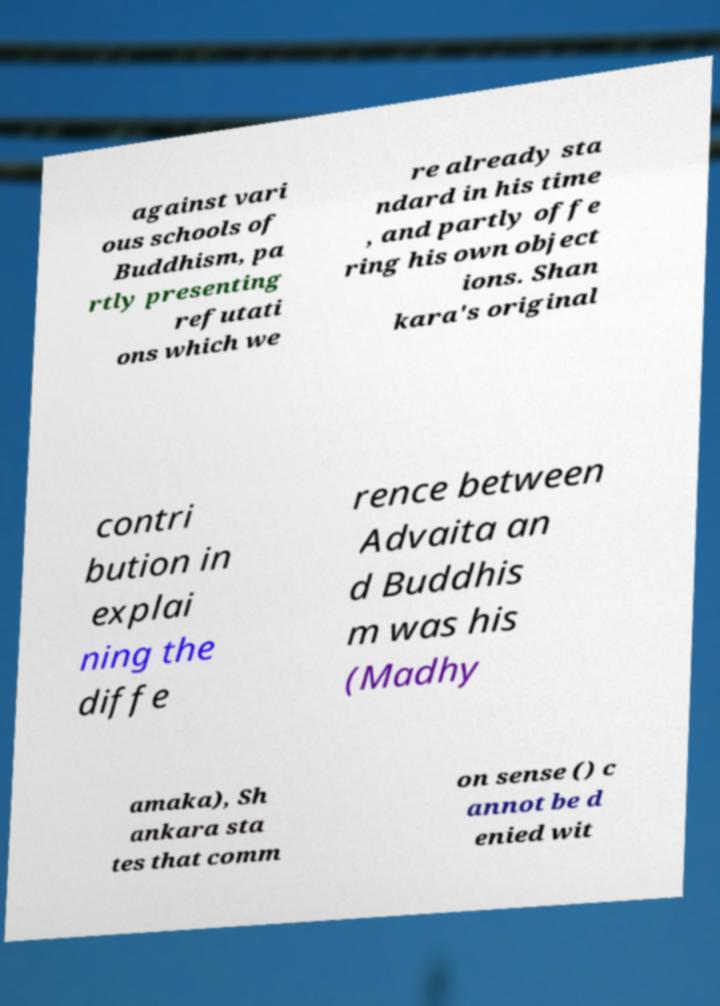I need the written content from this picture converted into text. Can you do that? against vari ous schools of Buddhism, pa rtly presenting refutati ons which we re already sta ndard in his time , and partly offe ring his own object ions. Shan kara's original contri bution in explai ning the diffe rence between Advaita an d Buddhis m was his (Madhy amaka), Sh ankara sta tes that comm on sense () c annot be d enied wit 